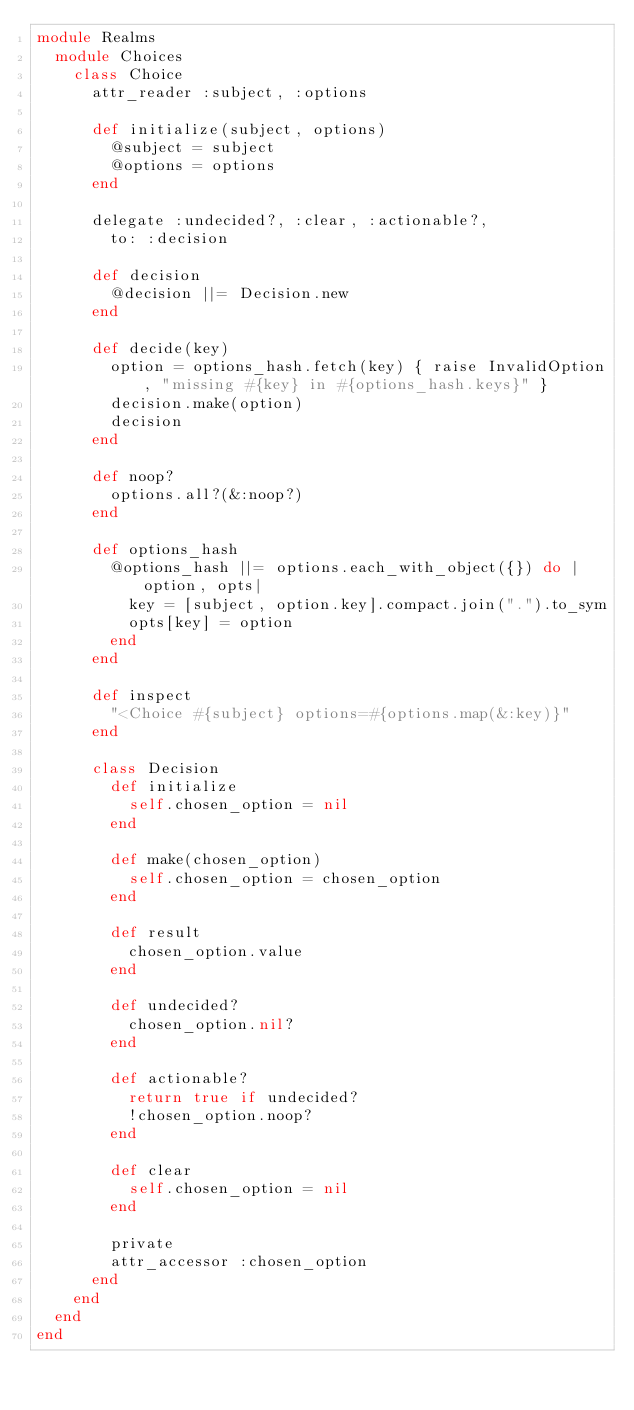<code> <loc_0><loc_0><loc_500><loc_500><_Ruby_>module Realms
  module Choices
    class Choice
      attr_reader :subject, :options

      def initialize(subject, options)
        @subject = subject
        @options = options
      end

      delegate :undecided?, :clear, :actionable?,
        to: :decision

      def decision
        @decision ||= Decision.new
      end

      def decide(key)
        option = options_hash.fetch(key) { raise InvalidOption, "missing #{key} in #{options_hash.keys}" }
        decision.make(option)
        decision
      end

      def noop?
        options.all?(&:noop?)
      end

      def options_hash
        @options_hash ||= options.each_with_object({}) do |option, opts|
          key = [subject, option.key].compact.join(".").to_sym
          opts[key] = option
        end
      end

      def inspect
        "<Choice #{subject} options=#{options.map(&:key)}"
      end

      class Decision
        def initialize
          self.chosen_option = nil
        end

        def make(chosen_option)
          self.chosen_option = chosen_option
        end

        def result
          chosen_option.value
        end

        def undecided?
          chosen_option.nil?
        end

        def actionable?
          return true if undecided?
          !chosen_option.noop?
        end

        def clear
          self.chosen_option = nil
        end

        private
        attr_accessor :chosen_option
      end
    end
  end
end
</code> 